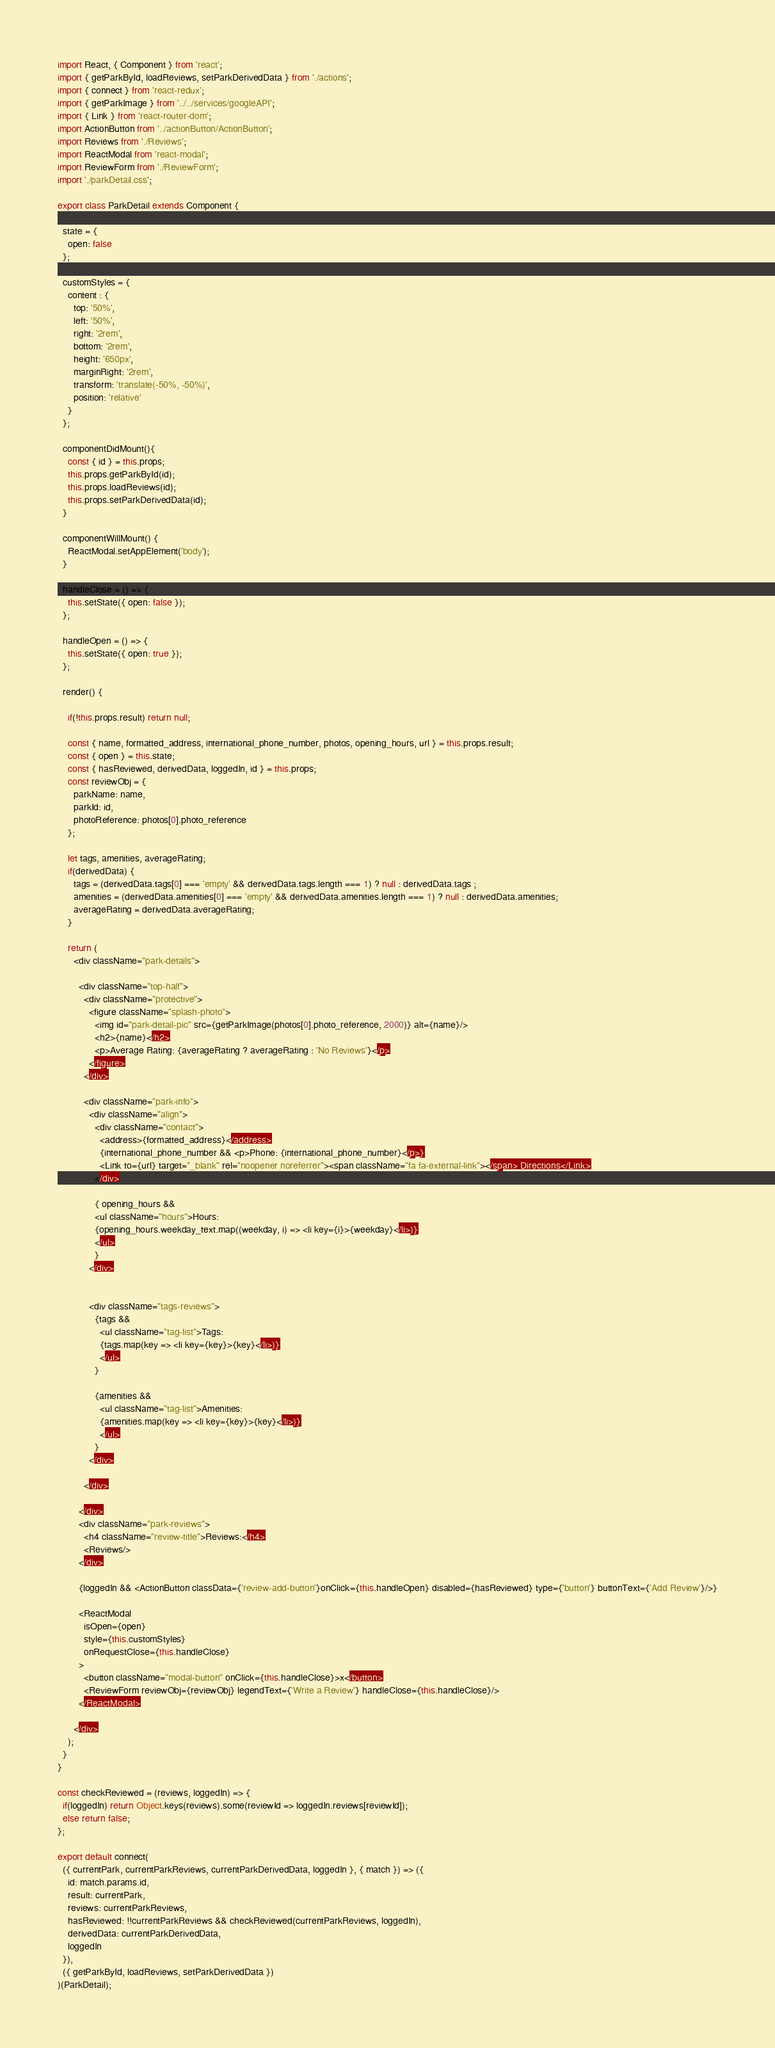<code> <loc_0><loc_0><loc_500><loc_500><_JavaScript_>import React, { Component } from 'react';
import { getParkById, loadReviews, setParkDerivedData } from './actions';
import { connect } from 'react-redux';
import { getParkImage } from '../../services/googleAPI';
import { Link } from 'react-router-dom';
import ActionButton from '../actionButton/ActionButton';
import Reviews from './Reviews';
import ReactModal from 'react-modal';
import ReviewForm from './ReviewForm';
import './parkDetail.css';

export class ParkDetail extends Component {

  state = {
    open: false
  };

  customStyles = {
    content : {
      top: '50%',
      left: '50%',
      right: '2rem',
      bottom: '2rem',
      height: '650px',
      marginRight: '2rem',
      transform: 'translate(-50%, -50%)',
      position: 'relative'
    }
  };

  componentDidMount(){
    const { id } = this.props;
    this.props.getParkById(id);
    this.props.loadReviews(id);
    this.props.setParkDerivedData(id);
  }

  componentWillMount() {
    ReactModal.setAppElement('body');
  }

  handleClose = () => {
    this.setState({ open: false });
  };

  handleOpen = () => {
    this.setState({ open: true });
  };

  render() {
    
    if(!this.props.result) return null;
    
    const { name, formatted_address, international_phone_number, photos, opening_hours, url } = this.props.result;
    const { open } = this.state;
    const { hasReviewed, derivedData, loggedIn, id } = this.props;
    const reviewObj = {
      parkName: name,
      parkId: id,
      photoReference: photos[0].photo_reference
    };
  
    let tags, amenities, averageRating;
    if(derivedData) {
      tags = (derivedData.tags[0] === 'empty' && derivedData.tags.length === 1) ? null : derivedData.tags ;
      amenities = (derivedData.amenities[0] === 'empty' && derivedData.amenities.length === 1) ? null : derivedData.amenities;
      averageRating = derivedData.averageRating;
    }

    return (
      <div className="park-details">

        <div className="top-half">
          <div className="protective">
            <figure className="splash-photo">
              <img id="park-detail-pic" src={getParkImage(photos[0].photo_reference, 2000)} alt={name}/>
              <h2>{name}</h2>
              <p>Average Rating: {averageRating ? averageRating : 'No Reviews'}</p>
            </figure>
          </div>

          <div className="park-info">
            <div className="align">
              <div className="contact">
                <address>{formatted_address}</address>
                {international_phone_number && <p>Phone: {international_phone_number}</p>}
                <Link to={url} target="_blank" rel="noopener noreferrer"><span className="fa fa-external-link"></span> Directions</Link>
              </div>

              { opening_hours && 
              <ul className="hours">Hours: 
              {opening_hours.weekday_text.map((weekday, i) => <li key={i}>{weekday}</li>)}
              </ul>
              }
            </div>


            <div className="tags-reviews">
              {tags && 
                <ul className="tag-list">Tags:
                {tags.map(key => <li key={key}>{key}</li>)}
                </ul>
              }

              {amenities && 
                <ul className="tag-list">Amenities: 
                {amenities.map(key => <li key={key}>{key}</li>)}
                </ul>
              }
            </div>

          </div>

        </div>
        <div className="park-reviews">
          <h4 className="review-title">Reviews:</h4>
          <Reviews/>
        </div>

        {loggedIn && <ActionButton classData={'review-add-button'}onClick={this.handleOpen} disabled={hasReviewed} type={'button'} buttonText={'Add Review'}/>}

        <ReactModal
          isOpen={open}
          style={this.customStyles}
          onRequestClose={this.handleClose}
        >
          <button className="modal-button" onClick={this.handleClose}>x</button>
          <ReviewForm reviewObj={reviewObj} legendText={'Write a Review'} handleClose={this.handleClose}/>
        </ReactModal>

      </div>
    );
  }
}

const checkReviewed = (reviews, loggedIn) => {
  if(loggedIn) return Object.keys(reviews).some(reviewId => loggedIn.reviews[reviewId]); 
  else return false;
};

export default connect(
  ({ currentPark, currentParkReviews, currentParkDerivedData, loggedIn }, { match }) => ({
    id: match.params.id,
    result: currentPark,
    reviews: currentParkReviews,
    hasReviewed: !!currentParkReviews && checkReviewed(currentParkReviews, loggedIn),
    derivedData: currentParkDerivedData,
    loggedIn
  }),
  ({ getParkById, loadReviews, setParkDerivedData })
)(ParkDetail);</code> 